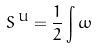Convert formula to latex. <formula><loc_0><loc_0><loc_500><loc_500>S \, ^ { U } = \frac { 1 } { 2 } \int \omega</formula> 